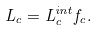Convert formula to latex. <formula><loc_0><loc_0><loc_500><loc_500>L _ { c } = L _ { c } ^ { i n t } f _ { c } .</formula> 